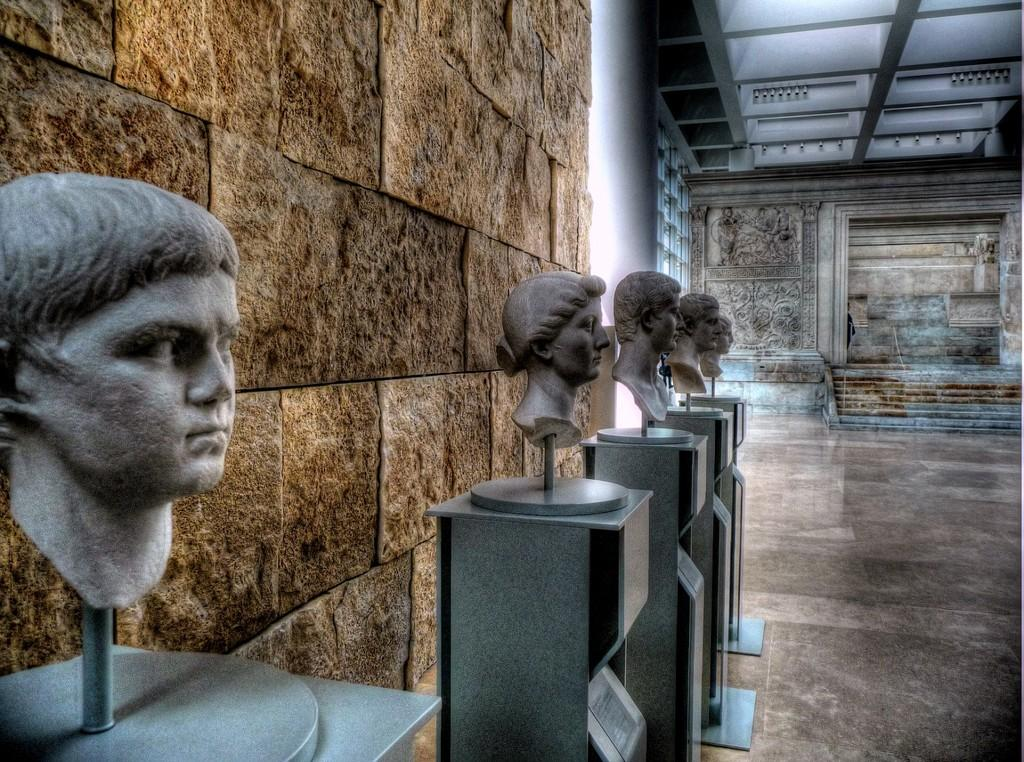What is the main subject of the image? The main subject of the image is the statues of heads on a stand. What is visible behind the statues? There is a brick wall behind the statues. What type of art can be seen in the image? There is a wall with some art in the back. Are there any architectural features in the image? Yes, there are steps in the image. What type of creature is sitting on the steps in the image? There is no creature present on the steps in the image. What type of cloth is draped over the statues in the image? There is no cloth draped over the statues in the image. 